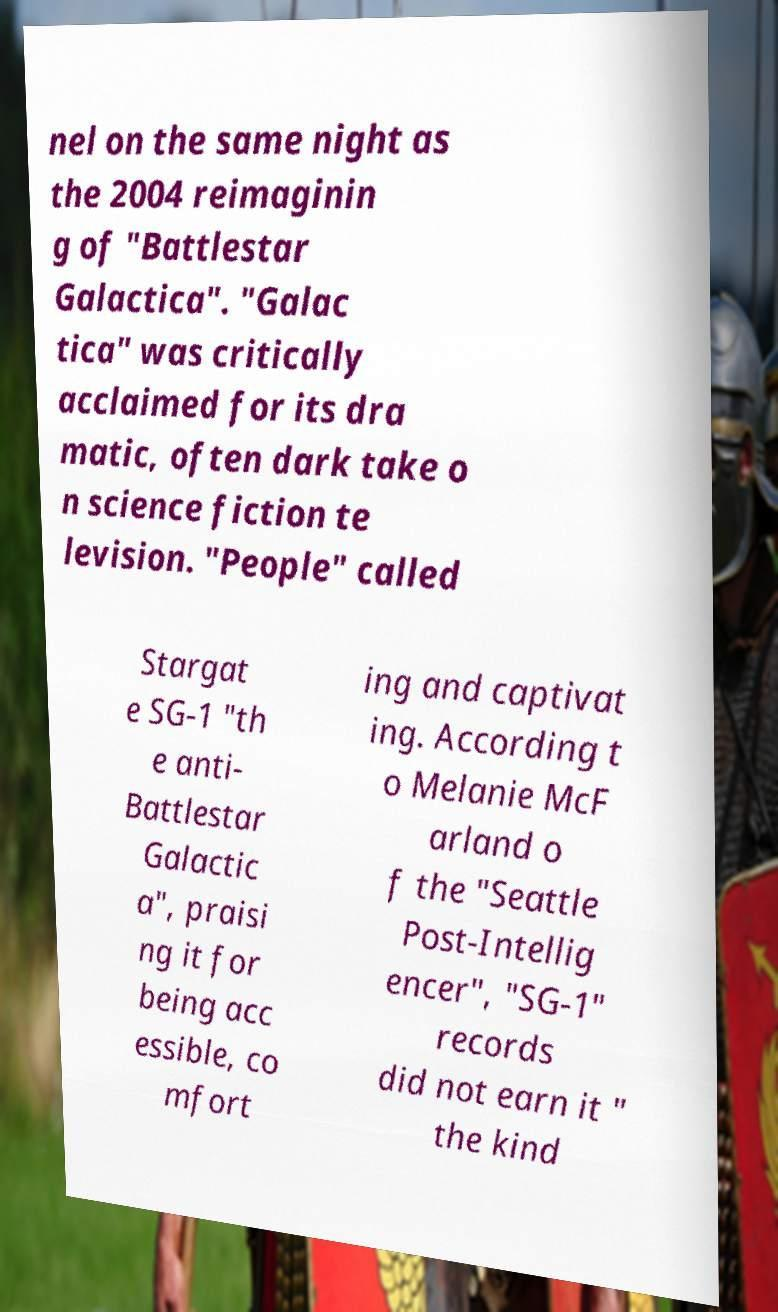Could you assist in decoding the text presented in this image and type it out clearly? nel on the same night as the 2004 reimaginin g of "Battlestar Galactica". "Galac tica" was critically acclaimed for its dra matic, often dark take o n science fiction te levision. "People" called Stargat e SG-1 "th e anti- Battlestar Galactic a", praisi ng it for being acc essible, co mfort ing and captivat ing. According t o Melanie McF arland o f the "Seattle Post-Intellig encer", "SG-1" records did not earn it " the kind 